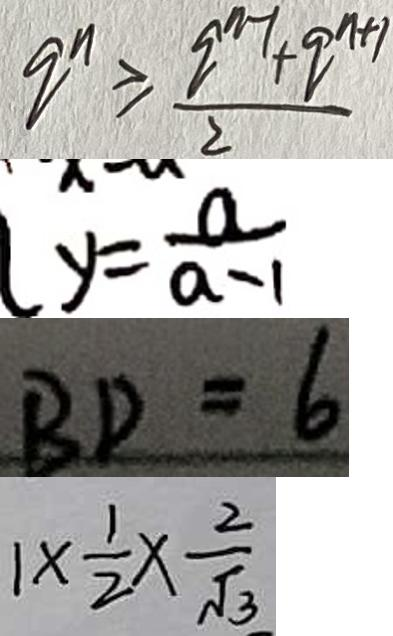Convert formula to latex. <formula><loc_0><loc_0><loc_500><loc_500>q ^ { n } \geq \frac { q ^ { n - 1 } + q ^ { n + 1 } } { 2 } 
 y = \frac { a } { a - 1 } 
 B D = 6 
 1 \times \frac { 1 } { 2 } \times \frac { 2 } { \sqrt { 3 } }</formula> 